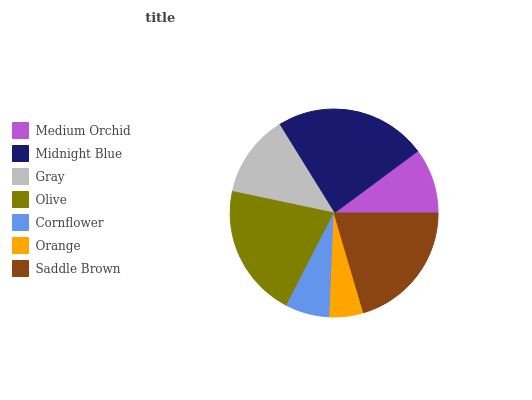Is Orange the minimum?
Answer yes or no. Yes. Is Midnight Blue the maximum?
Answer yes or no. Yes. Is Gray the minimum?
Answer yes or no. No. Is Gray the maximum?
Answer yes or no. No. Is Midnight Blue greater than Gray?
Answer yes or no. Yes. Is Gray less than Midnight Blue?
Answer yes or no. Yes. Is Gray greater than Midnight Blue?
Answer yes or no. No. Is Midnight Blue less than Gray?
Answer yes or no. No. Is Gray the high median?
Answer yes or no. Yes. Is Gray the low median?
Answer yes or no. Yes. Is Medium Orchid the high median?
Answer yes or no. No. Is Midnight Blue the low median?
Answer yes or no. No. 